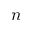Convert formula to latex. <formula><loc_0><loc_0><loc_500><loc_500>n</formula> 